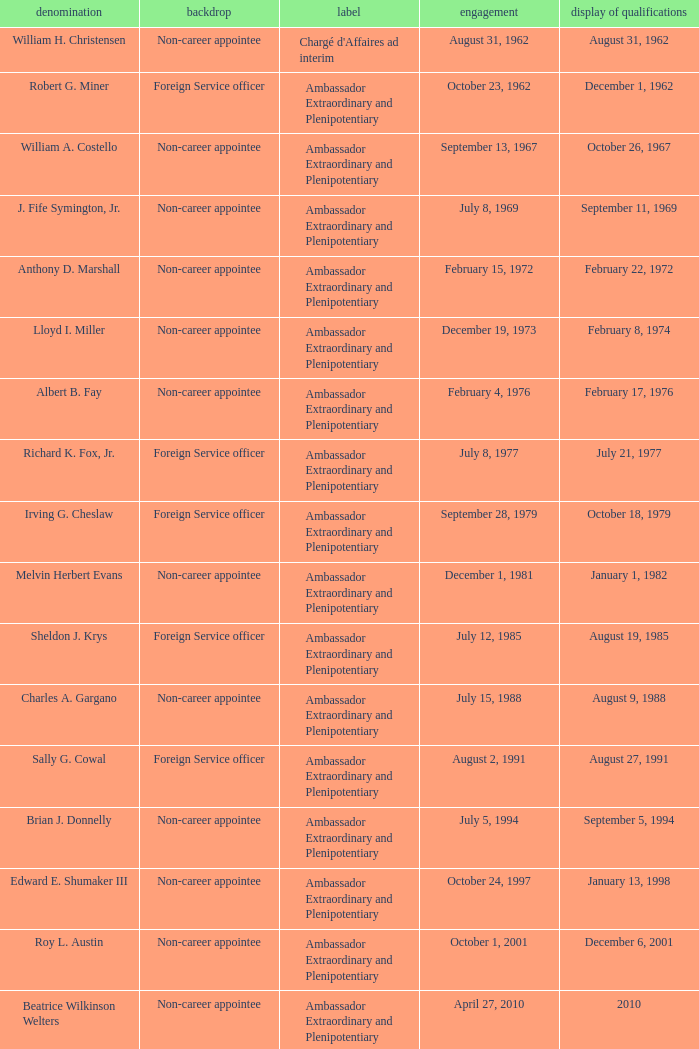Can you give me this table as a dict? {'header': ['denomination', 'backdrop', 'label', 'engagement', 'display of qualifications'], 'rows': [['William H. Christensen', 'Non-career appointee', "Chargé d'Affaires ad interim", 'August 31, 1962', 'August 31, 1962'], ['Robert G. Miner', 'Foreign Service officer', 'Ambassador Extraordinary and Plenipotentiary', 'October 23, 1962', 'December 1, 1962'], ['William A. Costello', 'Non-career appointee', 'Ambassador Extraordinary and Plenipotentiary', 'September 13, 1967', 'October 26, 1967'], ['J. Fife Symington, Jr.', 'Non-career appointee', 'Ambassador Extraordinary and Plenipotentiary', 'July 8, 1969', 'September 11, 1969'], ['Anthony D. Marshall', 'Non-career appointee', 'Ambassador Extraordinary and Plenipotentiary', 'February 15, 1972', 'February 22, 1972'], ['Lloyd I. Miller', 'Non-career appointee', 'Ambassador Extraordinary and Plenipotentiary', 'December 19, 1973', 'February 8, 1974'], ['Albert B. Fay', 'Non-career appointee', 'Ambassador Extraordinary and Plenipotentiary', 'February 4, 1976', 'February 17, 1976'], ['Richard K. Fox, Jr.', 'Foreign Service officer', 'Ambassador Extraordinary and Plenipotentiary', 'July 8, 1977', 'July 21, 1977'], ['Irving G. Cheslaw', 'Foreign Service officer', 'Ambassador Extraordinary and Plenipotentiary', 'September 28, 1979', 'October 18, 1979'], ['Melvin Herbert Evans', 'Non-career appointee', 'Ambassador Extraordinary and Plenipotentiary', 'December 1, 1981', 'January 1, 1982'], ['Sheldon J. Krys', 'Foreign Service officer', 'Ambassador Extraordinary and Plenipotentiary', 'July 12, 1985', 'August 19, 1985'], ['Charles A. Gargano', 'Non-career appointee', 'Ambassador Extraordinary and Plenipotentiary', 'July 15, 1988', 'August 9, 1988'], ['Sally G. Cowal', 'Foreign Service officer', 'Ambassador Extraordinary and Plenipotentiary', 'August 2, 1991', 'August 27, 1991'], ['Brian J. Donnelly', 'Non-career appointee', 'Ambassador Extraordinary and Plenipotentiary', 'July 5, 1994', 'September 5, 1994'], ['Edward E. Shumaker III', 'Non-career appointee', 'Ambassador Extraordinary and Plenipotentiary', 'October 24, 1997', 'January 13, 1998'], ['Roy L. Austin', 'Non-career appointee', 'Ambassador Extraordinary and Plenipotentiary', 'October 1, 2001', 'December 6, 2001'], ['Beatrice Wilkinson Welters', 'Non-career appointee', 'Ambassador Extraordinary and Plenipotentiary', 'April 27, 2010', '2010'], ['Margaret B. Diop', 'Foreign Service officer', "Chargé d'Affaires ad interim", 'October 2012', 'Unknown']]} Who was appointed on October 24, 1997? Edward E. Shumaker III. 